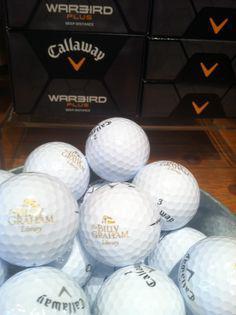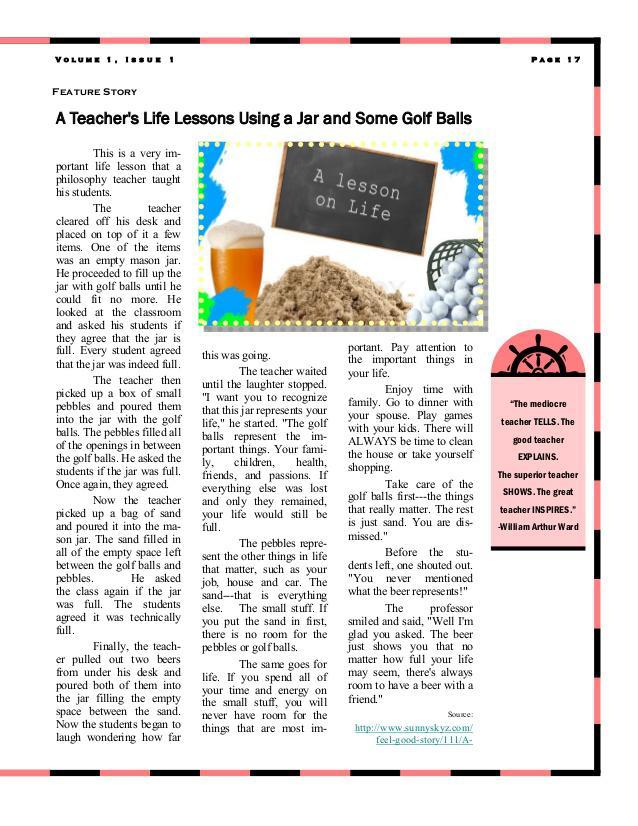The first image is the image on the left, the second image is the image on the right. Evaluate the accuracy of this statement regarding the images: "There is a glass of beer visible in one of the images.". Is it true? Answer yes or no. Yes. The first image is the image on the left, the second image is the image on the right. Considering the images on both sides, is "In at least one image there is at least one empty and full jar of golf balls." valid? Answer yes or no. No. 